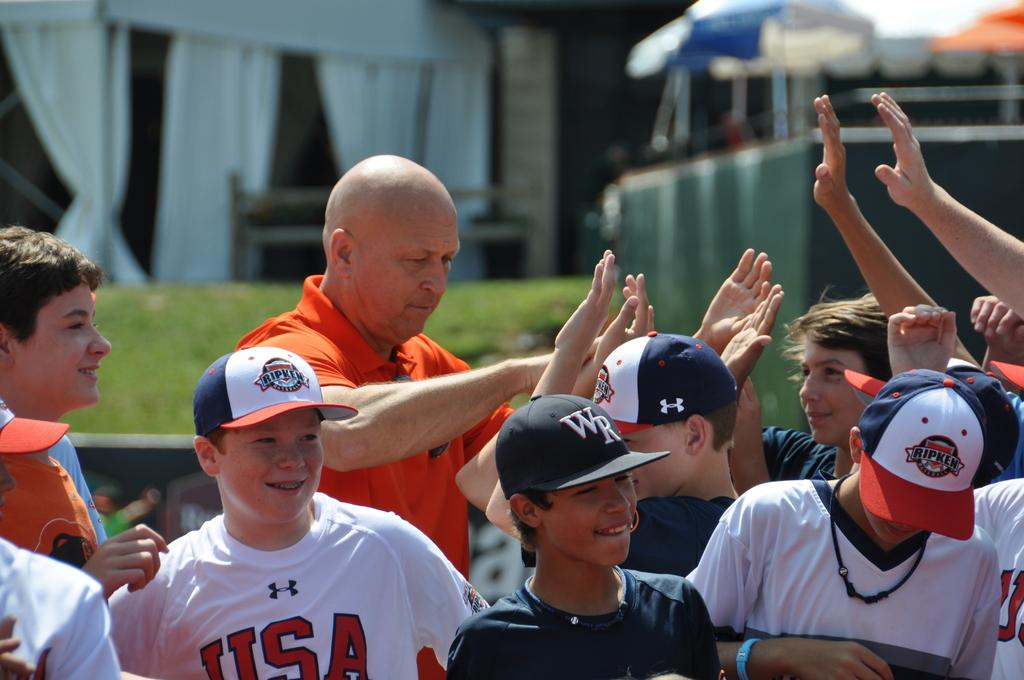<image>
Describe the image concisely. Many young athletes smile while wearing different hats and shirts, including one for USA and a hat that says WR. 